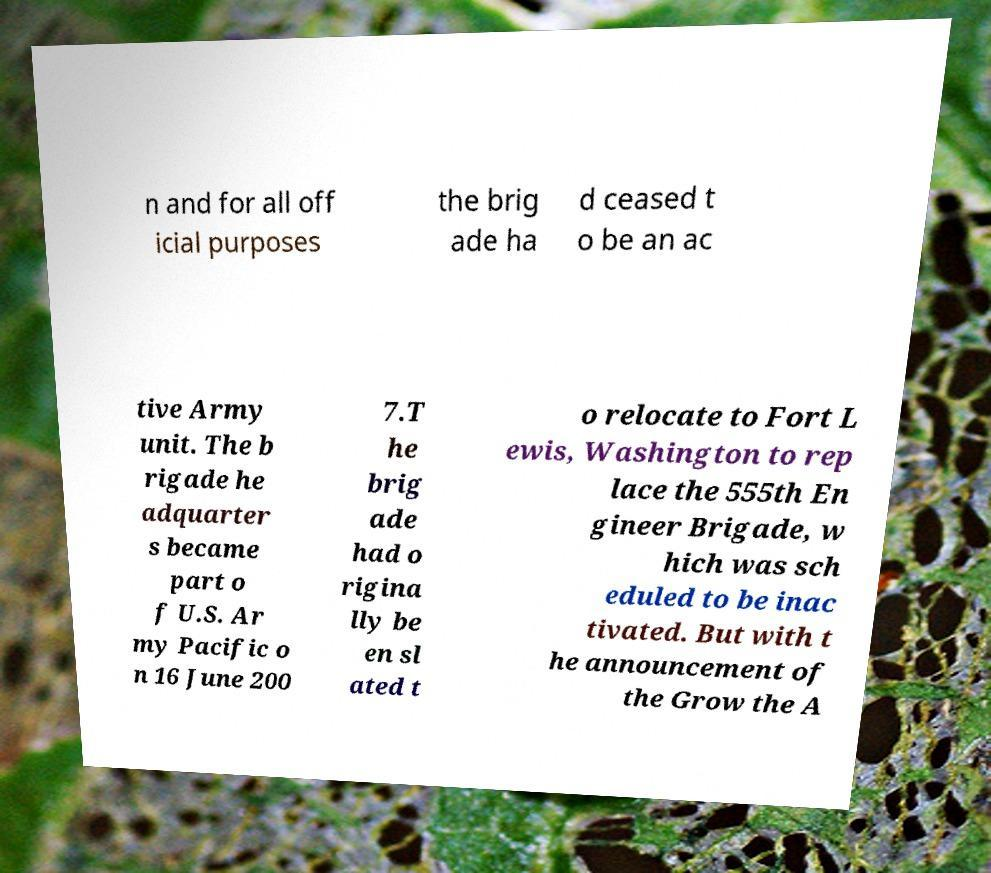What messages or text are displayed in this image? I need them in a readable, typed format. n and for all off icial purposes the brig ade ha d ceased t o be an ac tive Army unit. The b rigade he adquarter s became part o f U.S. Ar my Pacific o n 16 June 200 7.T he brig ade had o rigina lly be en sl ated t o relocate to Fort L ewis, Washington to rep lace the 555th En gineer Brigade, w hich was sch eduled to be inac tivated. But with t he announcement of the Grow the A 